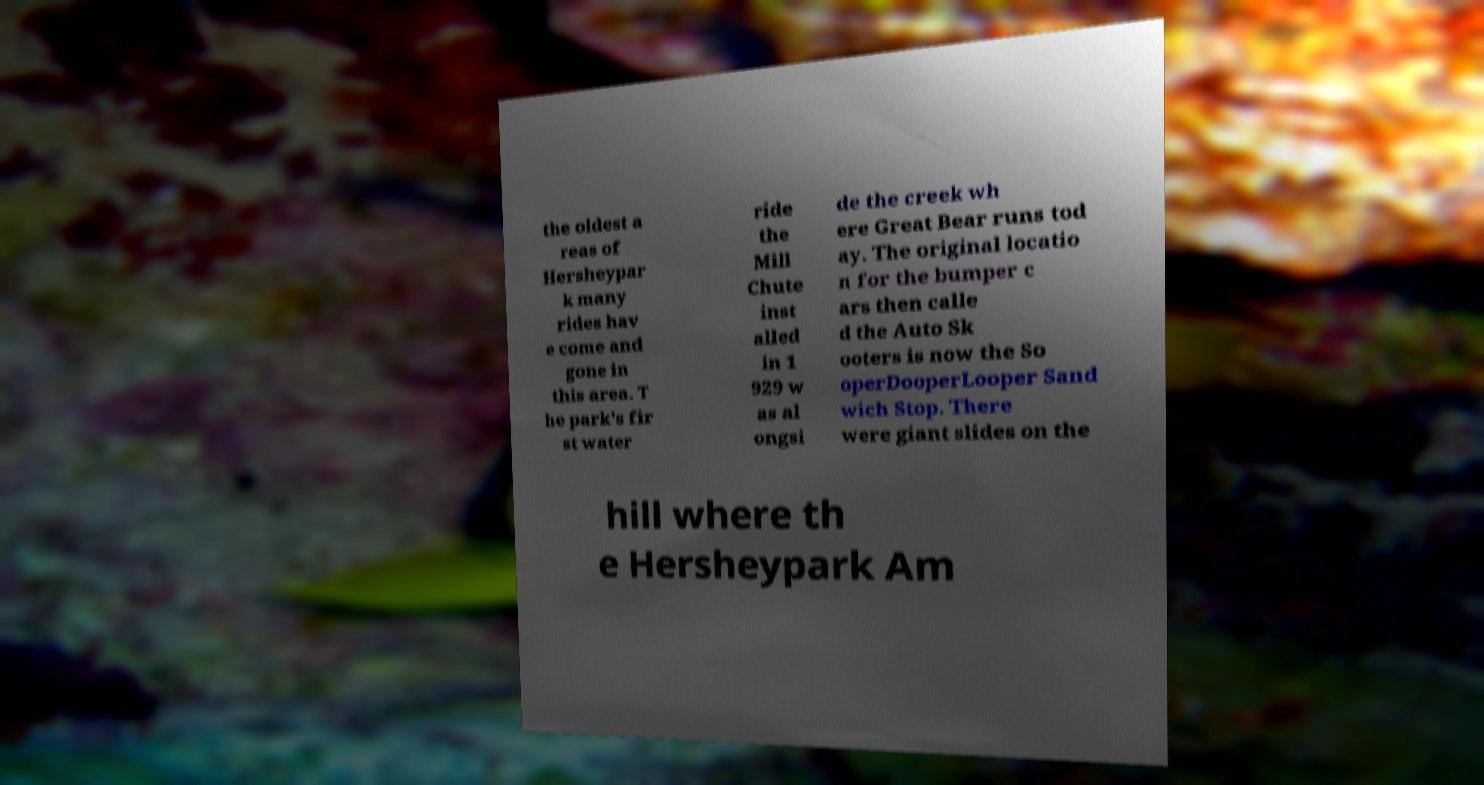Please identify and transcribe the text found in this image. the oldest a reas of Hersheypar k many rides hav e come and gone in this area. T he park's fir st water ride the Mill Chute inst alled in 1 929 w as al ongsi de the creek wh ere Great Bear runs tod ay. The original locatio n for the bumper c ars then calle d the Auto Sk ooters is now the So operDooperLooper Sand wich Stop. There were giant slides on the hill where th e Hersheypark Am 